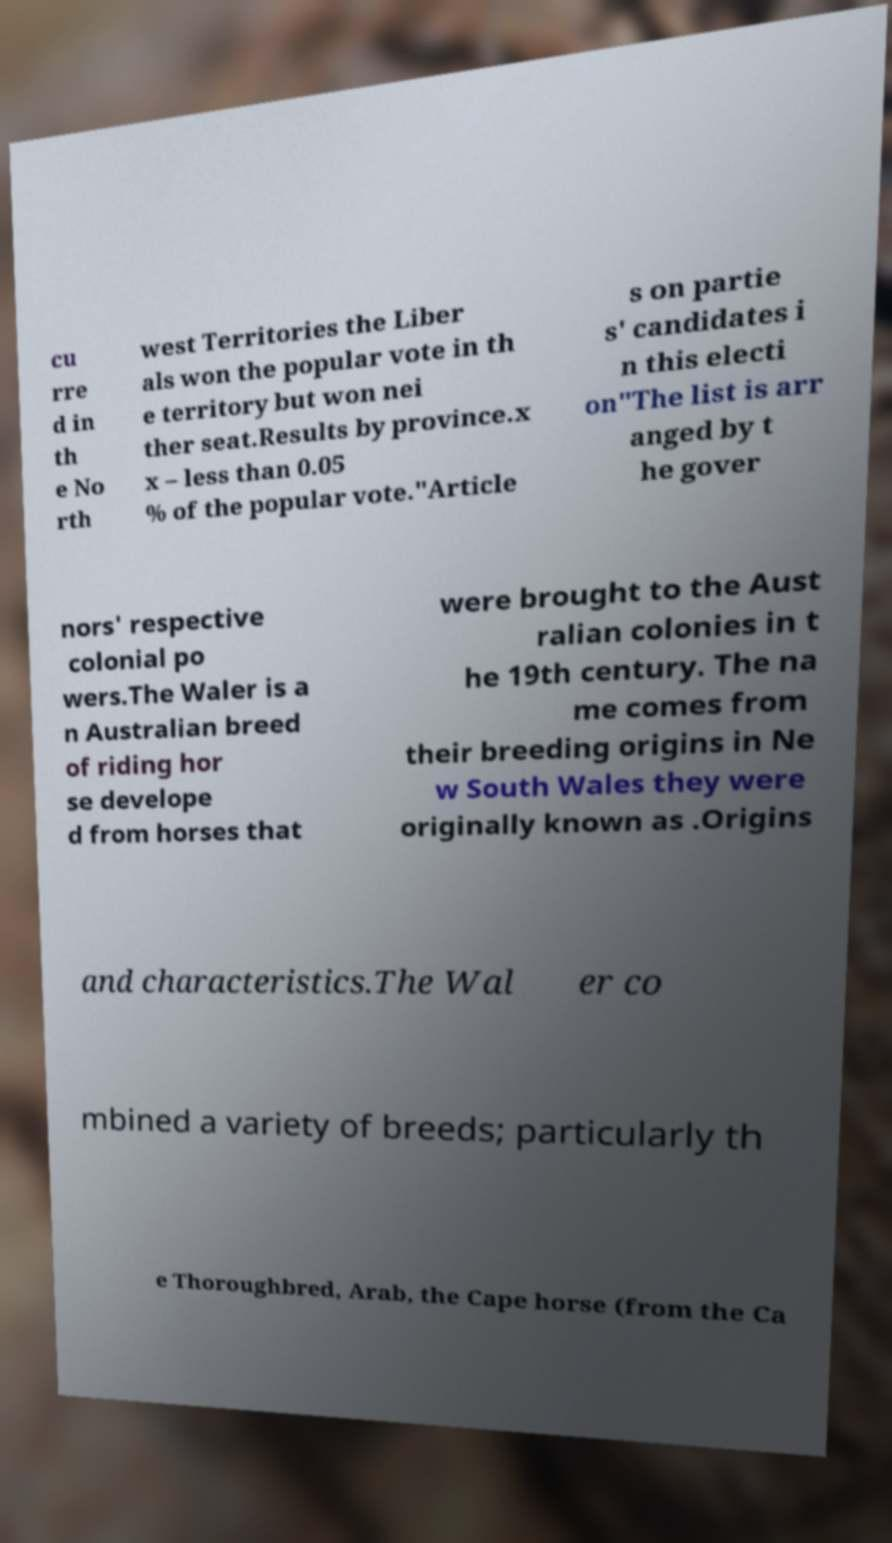Please read and relay the text visible in this image. What does it say? cu rre d in th e No rth west Territories the Liber als won the popular vote in th e territory but won nei ther seat.Results by province.x x – less than 0.05 % of the popular vote."Article s on partie s' candidates i n this electi on"The list is arr anged by t he gover nors' respective colonial po wers.The Waler is a n Australian breed of riding hor se develope d from horses that were brought to the Aust ralian colonies in t he 19th century. The na me comes from their breeding origins in Ne w South Wales they were originally known as .Origins and characteristics.The Wal er co mbined a variety of breeds; particularly th e Thoroughbred, Arab, the Cape horse (from the Ca 